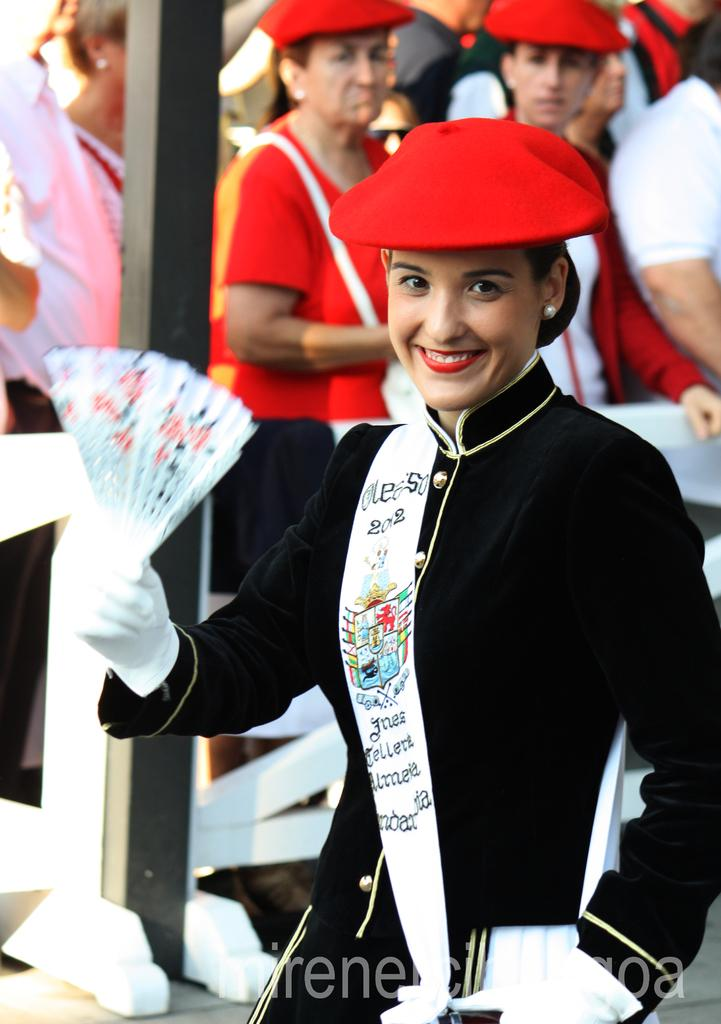What is happening in the image? There are people standing in the image. Can you describe any specific actions or interactions among the people? One person is holding an object. Are there any accessories or clothing items that stand out in the image? Some people are wearing caps. What else can be seen in the image? There is a pole in the image. What type of apparatus is being used by the person holding the object in the image? There is no apparatus visible in the image; the person is simply holding an object. Can you tell me how many pickles are on the pole in the image? There are no pickles present in the image; the pole is not related to pickles. 